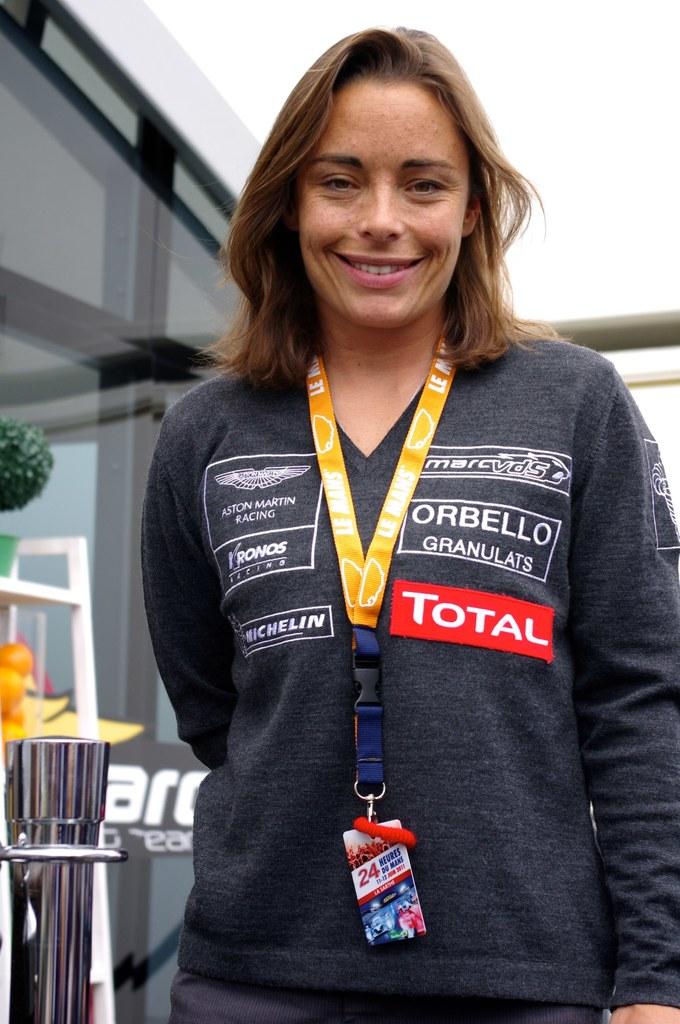Which company is she representing?
Your answer should be compact. Total. 